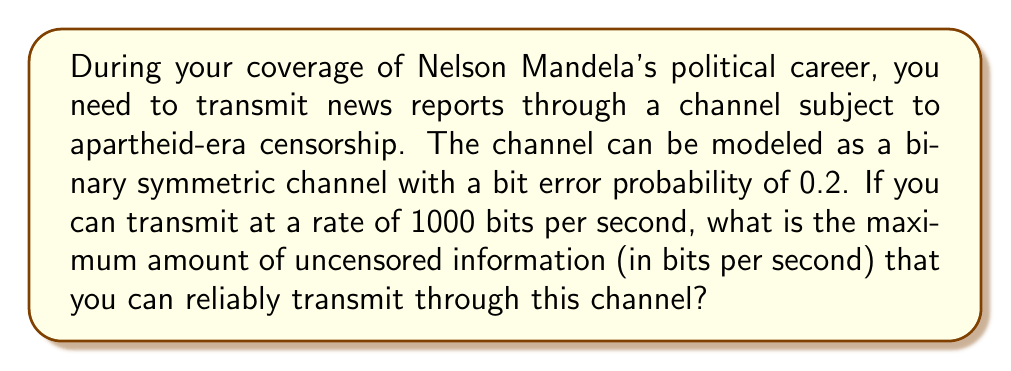Provide a solution to this math problem. To solve this problem, we need to calculate the channel capacity of a binary symmetric channel (BSC) under the given conditions. Let's approach this step-by-step:

1. The channel capacity (C) for a BSC is given by the formula:

   $$C = 1 - H(p)$$

   Where H(p) is the binary entropy function and p is the bit error probability.

2. The binary entropy function is defined as:

   $$H(p) = -p \log_2(p) - (1-p) \log_2(1-p)$$

3. Given: p = 0.2 (bit error probability)

4. Let's calculate H(0.2):

   $$\begin{align}
   H(0.2) &= -0.2 \log_2(0.2) - 0.8 \log_2(0.8) \\
   &\approx 0.2 \cdot 2.322 + 0.8 \cdot 0.322 \\
   &\approx 0.4644 + 0.2576 \\
   &\approx 0.722 \text{ bits}
   \end{align}$$

5. Now we can calculate the channel capacity:

   $$\begin{align}
   C &= 1 - H(0.2) \\
   &= 1 - 0.722 \\
   &\approx 0.278 \text{ bits per channel use}
   \end{align}$$

6. Given that we can transmit at a rate of 1000 bits per second, the maximum amount of uncensored information that can be reliably transmitted is:

   $$\begin{align}
   \text{Max information rate} &= 1000 \text{ bits/s} \cdot 0.278 \text{ bits/channel use} \\
   &= 278 \text{ bits/s}
   \end{align}$$

Therefore, you can reliably transmit up to 278 bits of uncensored information per second through this channel.
Answer: 278 bits per second 